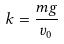Convert formula to latex. <formula><loc_0><loc_0><loc_500><loc_500>k = \frac { m g } { v _ { 0 } }</formula> 